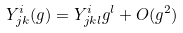<formula> <loc_0><loc_0><loc_500><loc_500>Y ^ { i } _ { j k } ( g ) = Y ^ { i } _ { j k l } g ^ { l } + O ( g ^ { 2 } )</formula> 